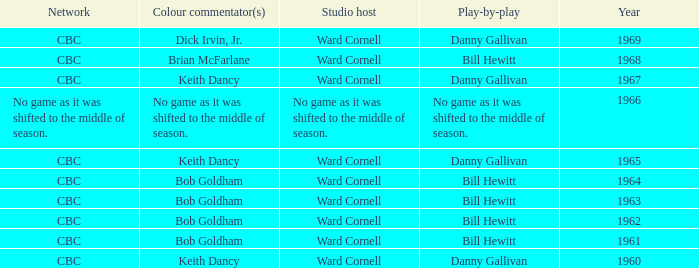I'm looking to parse the entire table for insights. Could you assist me with that? {'header': ['Network', 'Colour commentator(s)', 'Studio host', 'Play-by-play', 'Year'], 'rows': [['CBC', 'Dick Irvin, Jr.', 'Ward Cornell', 'Danny Gallivan', '1969'], ['CBC', 'Brian McFarlane', 'Ward Cornell', 'Bill Hewitt', '1968'], ['CBC', 'Keith Dancy', 'Ward Cornell', 'Danny Gallivan', '1967'], ['No game as it was shifted to the middle of season.', 'No game as it was shifted to the middle of season.', 'No game as it was shifted to the middle of season.', 'No game as it was shifted to the middle of season.', '1966'], ['CBC', 'Keith Dancy', 'Ward Cornell', 'Danny Gallivan', '1965'], ['CBC', 'Bob Goldham', 'Ward Cornell', 'Bill Hewitt', '1964'], ['CBC', 'Bob Goldham', 'Ward Cornell', 'Bill Hewitt', '1963'], ['CBC', 'Bob Goldham', 'Ward Cornell', 'Bill Hewitt', '1962'], ['CBC', 'Bob Goldham', 'Ward Cornell', 'Bill Hewitt', '1961'], ['CBC', 'Keith Dancy', 'Ward Cornell', 'Danny Gallivan', '1960']]} Who gave the play by play commentary with studio host Ward Cornell? Danny Gallivan, Bill Hewitt, Danny Gallivan, Danny Gallivan, Bill Hewitt, Bill Hewitt, Bill Hewitt, Bill Hewitt, Danny Gallivan. 